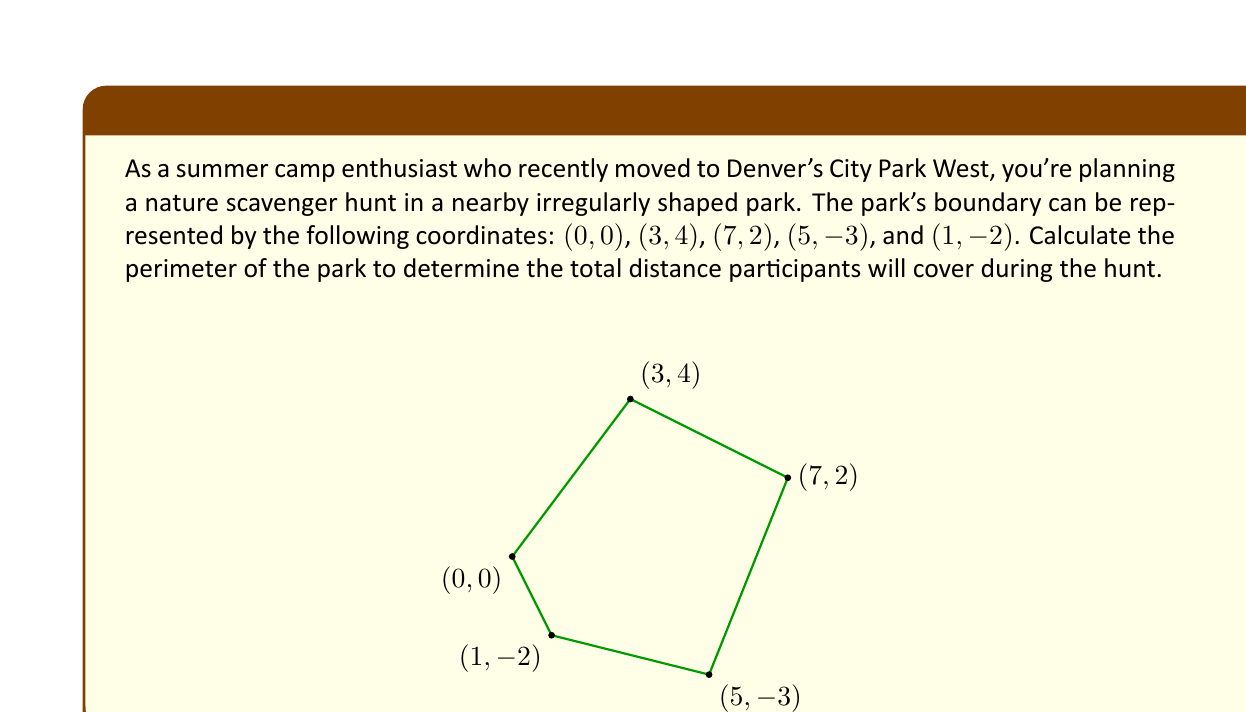Give your solution to this math problem. To calculate the perimeter of the irregularly shaped park, we need to find the distances between consecutive points and sum them up. We'll use the distance formula between two points $(x_1, y_1)$ and $(x_2, y_2)$:

$$d = \sqrt{(x_2 - x_1)^2 + (y_2 - y_1)^2}$$

Let's calculate each side length:

1) Side AB: $d_{AB} = \sqrt{(3-0)^2 + (4-0)^2} = \sqrt{9 + 16} = \sqrt{25} = 5$

2) Side BC: $d_{BC} = \sqrt{(7-3)^2 + (2-4)^2} = \sqrt{16 + 4} = \sqrt{20} = 2\sqrt{5}$

3) Side CD: $d_{CD} = \sqrt{(5-7)^2 + (-3-2)^2} = \sqrt{4 + 25} = \sqrt{29}$

4) Side DE: $d_{DE} = \sqrt{(1-5)^2 + (-2+3)^2} = \sqrt{16 + 1} = \sqrt{17}$

5) Side EA: $d_{EA} = \sqrt{(0-1)^2 + (0+2)^2} = \sqrt{1 + 4} = \sqrt{5}$

Now, we sum up all these distances to get the perimeter:

$$\text{Perimeter} = 5 + 2\sqrt{5} + \sqrt{29} + \sqrt{17} + \sqrt{5}$$

This expression cannot be simplified further, so this is our final answer.
Answer: $5 + 2\sqrt{5} + \sqrt{29} + \sqrt{17} + \sqrt{5}$ 